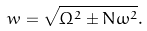<formula> <loc_0><loc_0><loc_500><loc_500>w = \sqrt { \Omega ^ { 2 } \pm N \omega ^ { 2 } } .</formula> 